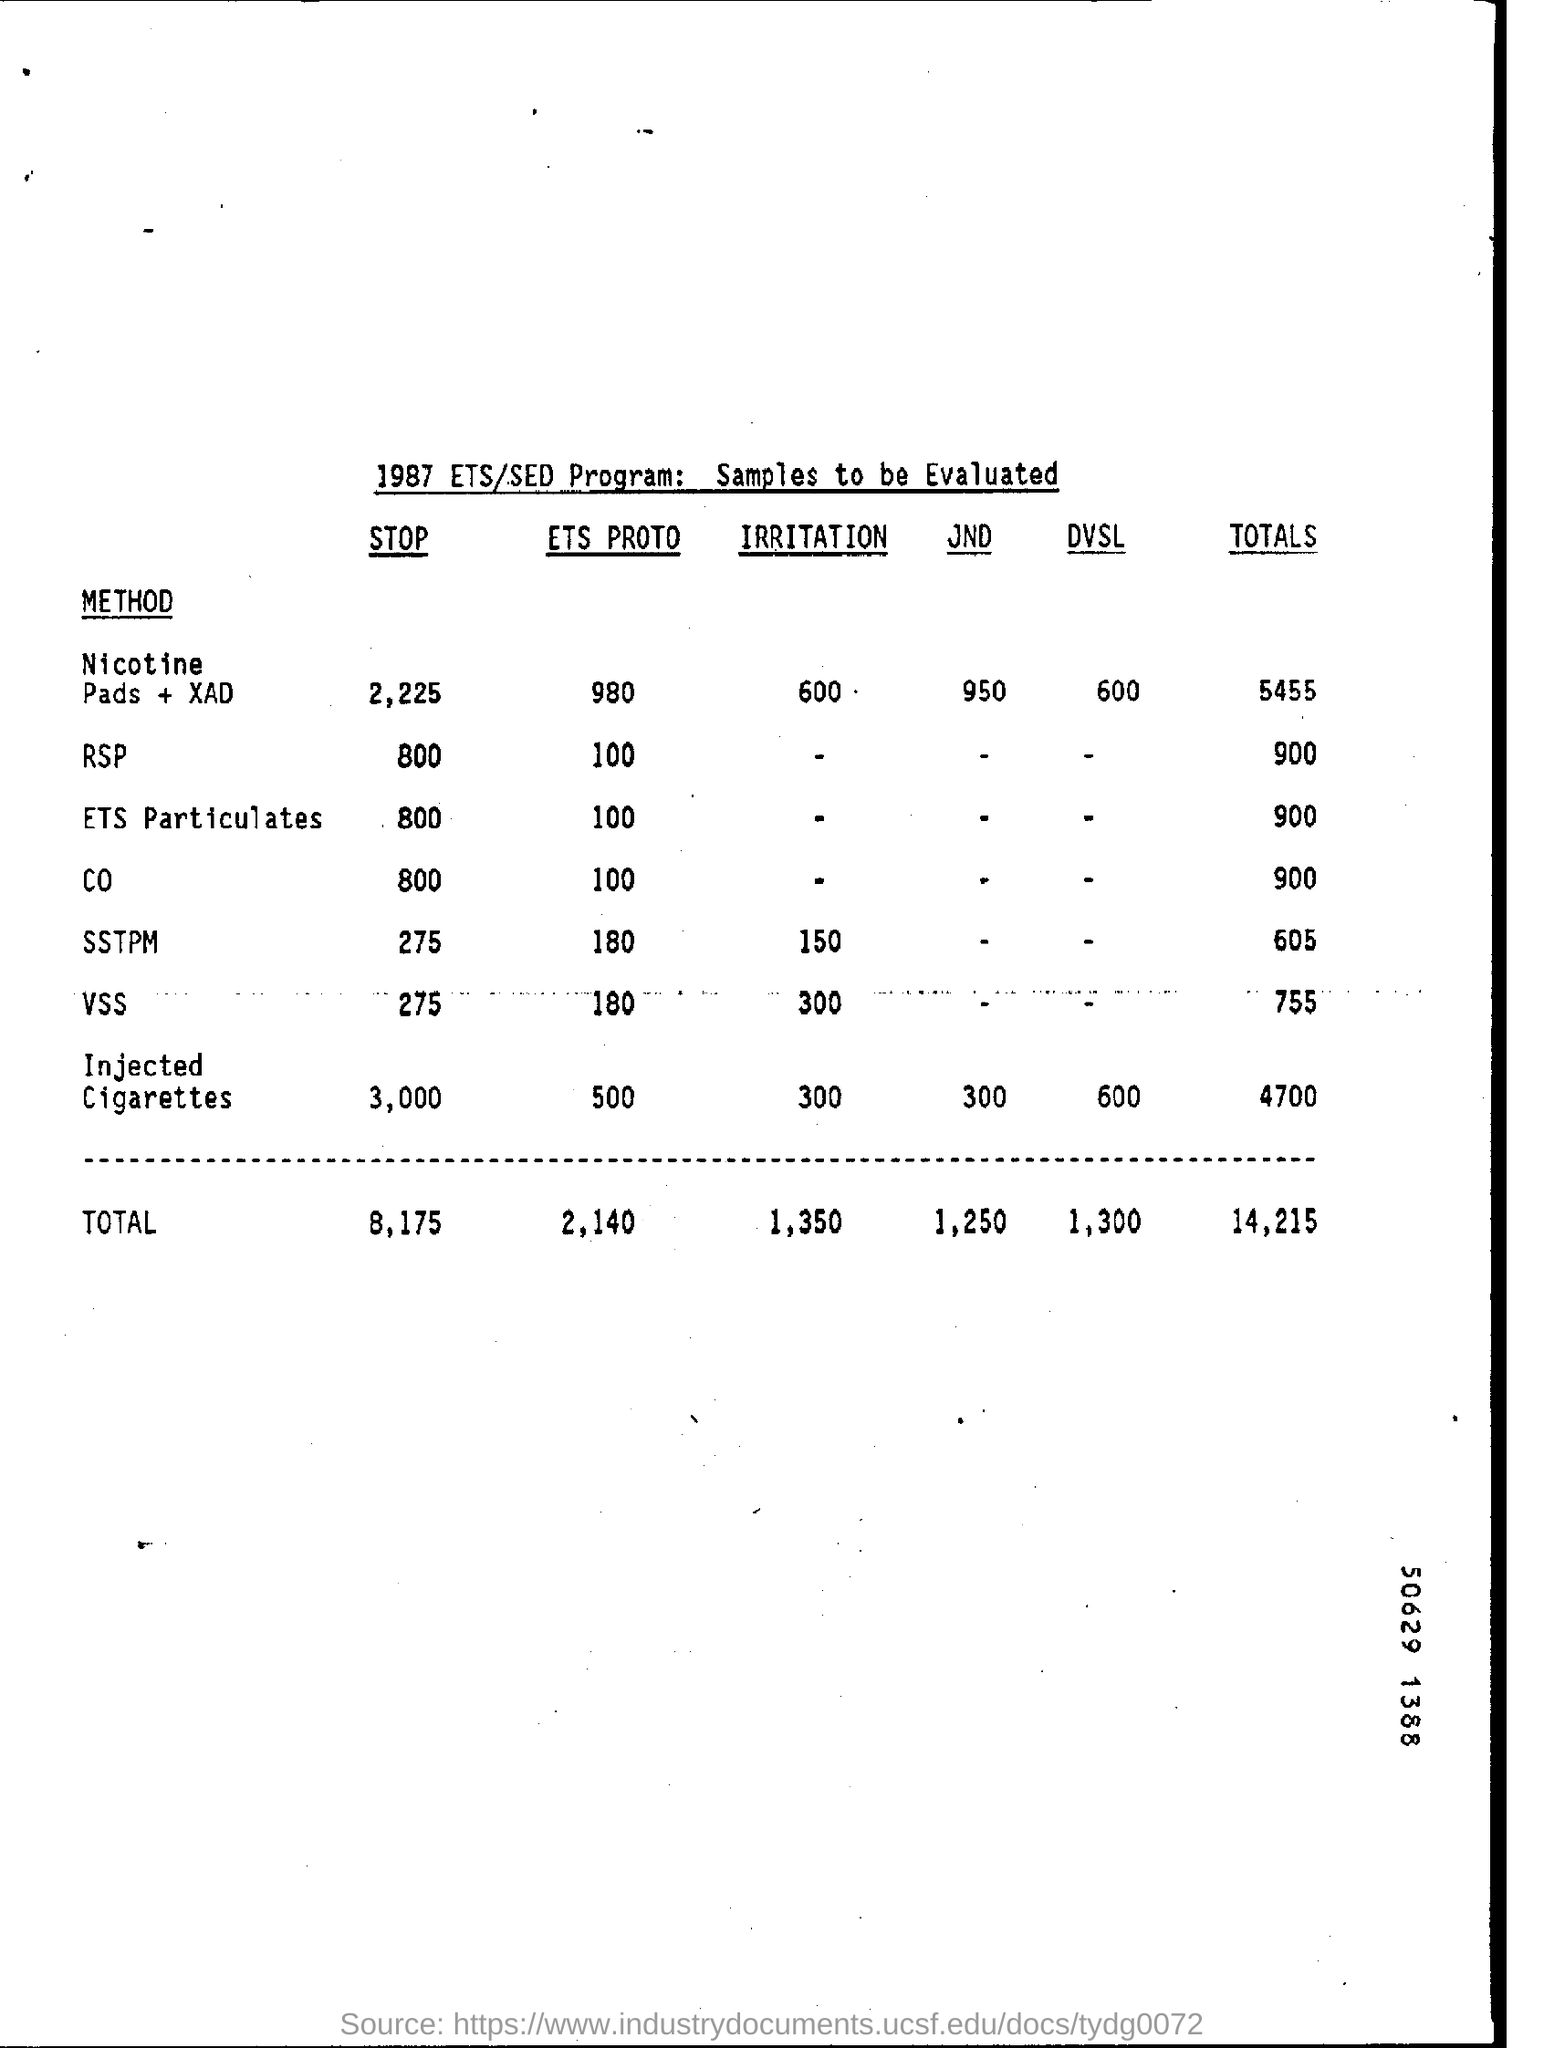What is ETS PROTO of ETS PARTICULATES?
Your answer should be very brief. 100. 